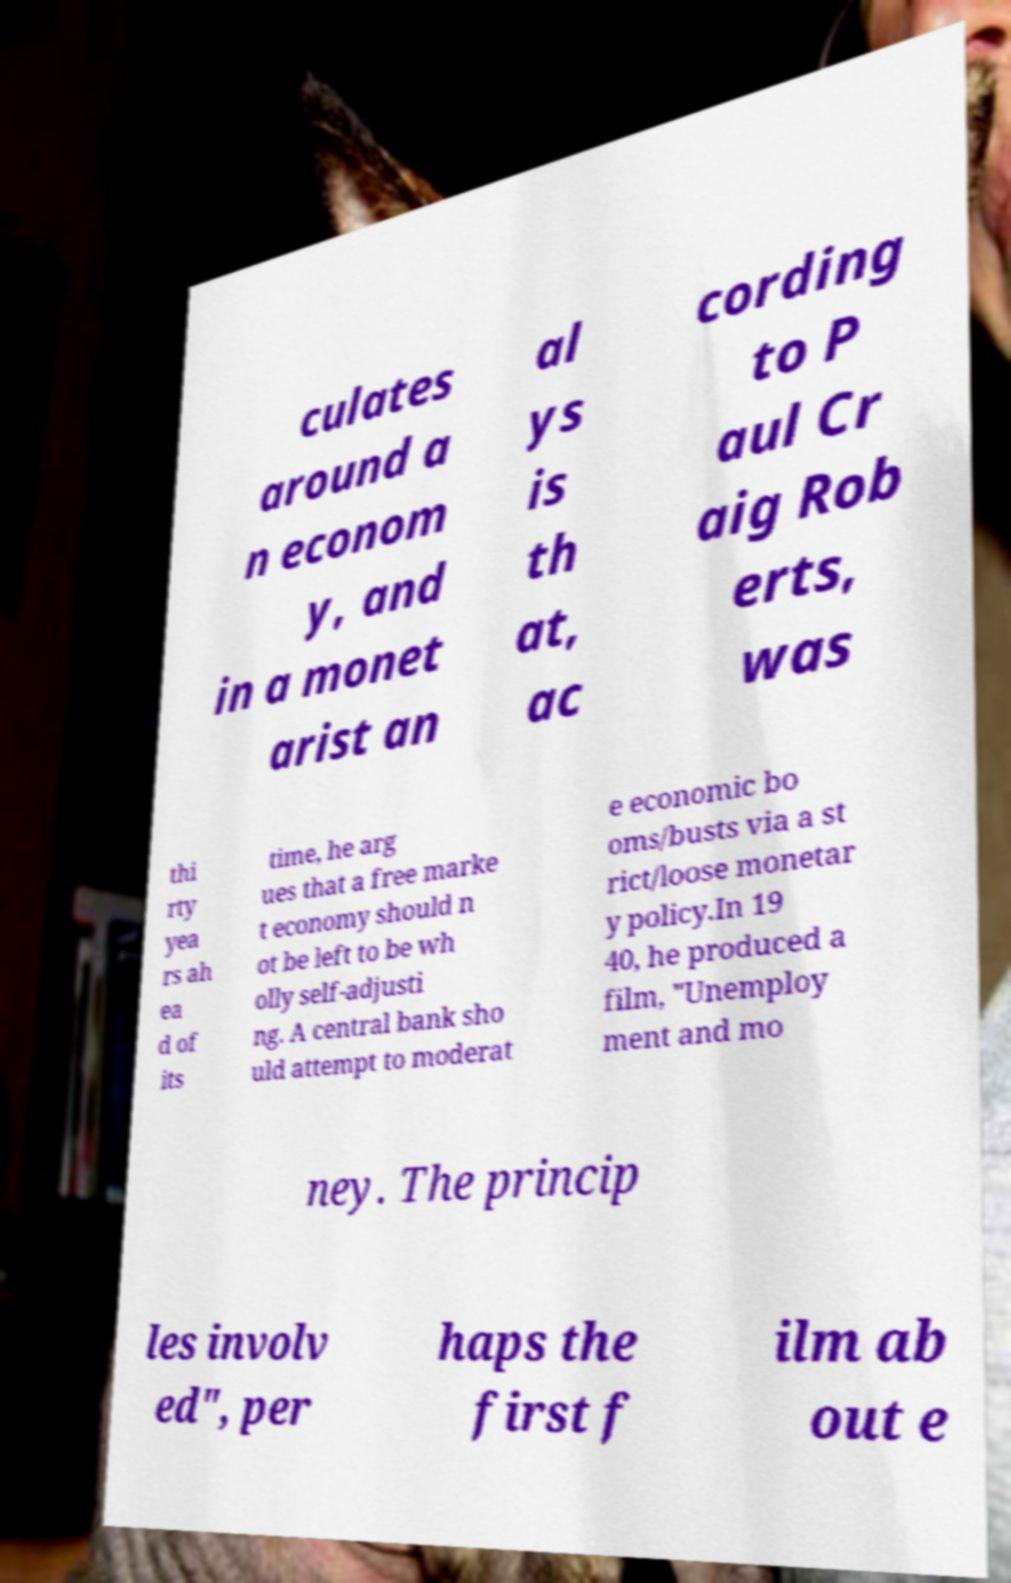What messages or text are displayed in this image? I need them in a readable, typed format. culates around a n econom y, and in a monet arist an al ys is th at, ac cording to P aul Cr aig Rob erts, was thi rty yea rs ah ea d of its time, he arg ues that a free marke t economy should n ot be left to be wh olly self-adjusti ng. A central bank sho uld attempt to moderat e economic bo oms/busts via a st rict/loose monetar y policy.In 19 40, he produced a film, "Unemploy ment and mo ney. The princip les involv ed", per haps the first f ilm ab out e 